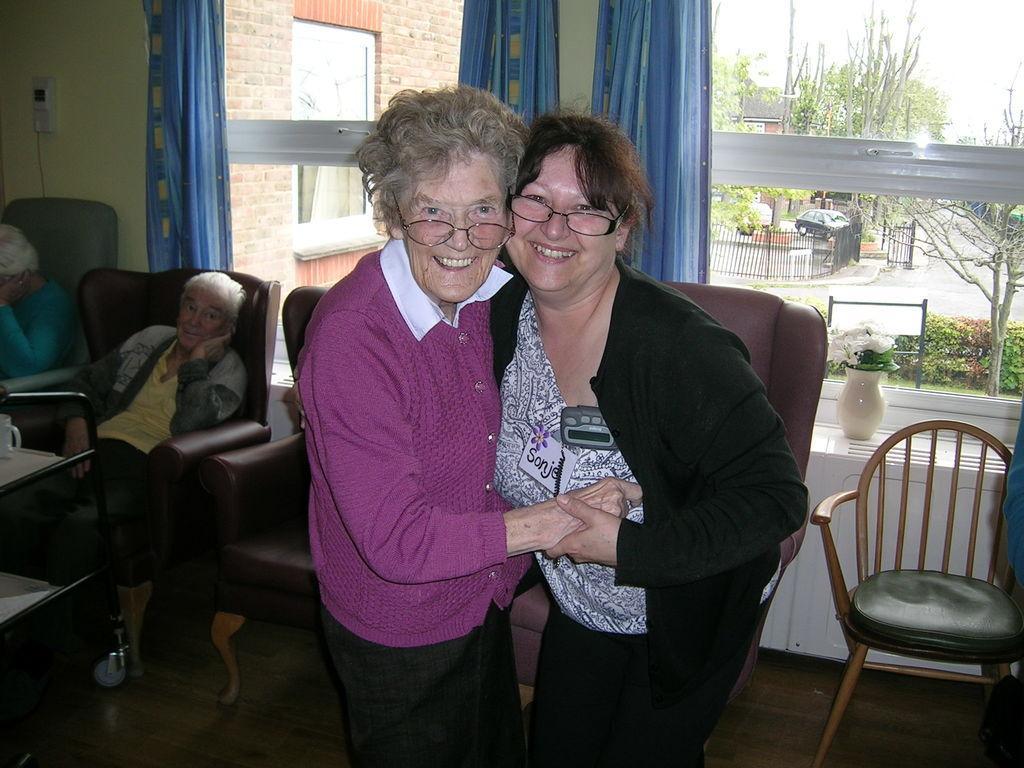In one or two sentences, can you explain what this image depicts? Both woman in the middle they are very happy ,they both have short hair and they both are wearing spectacles. To the left there is a man, he is looking towards two women ,in the back ground there is a window ,curtain and plants. To the right there is a empty chair. 